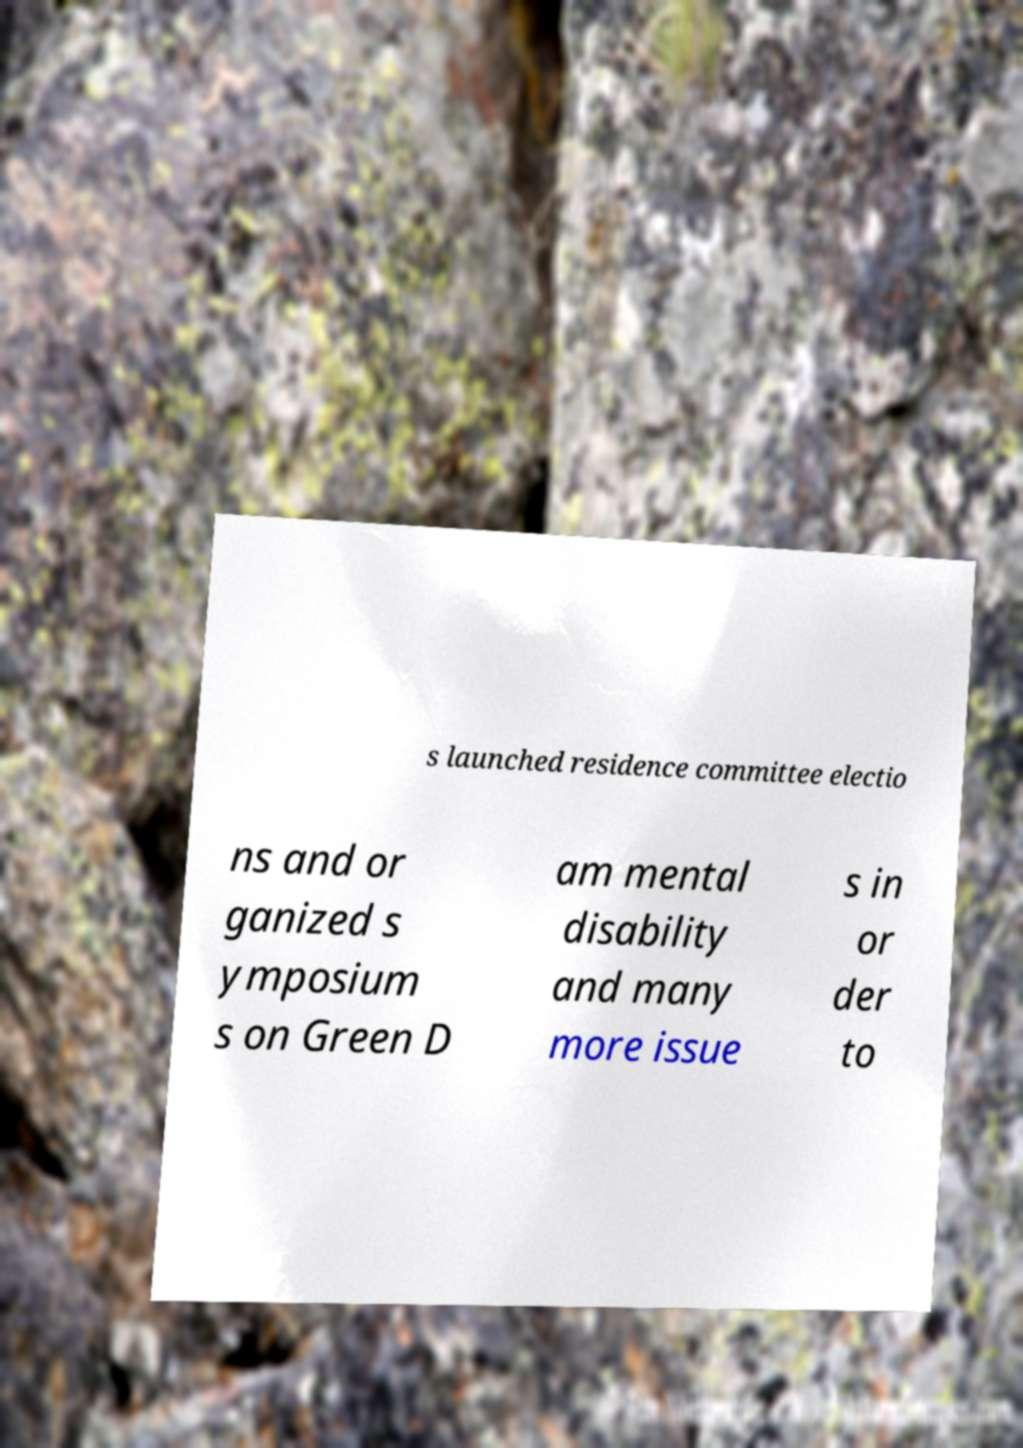What messages or text are displayed in this image? I need them in a readable, typed format. s launched residence committee electio ns and or ganized s ymposium s on Green D am mental disability and many more issue s in or der to 